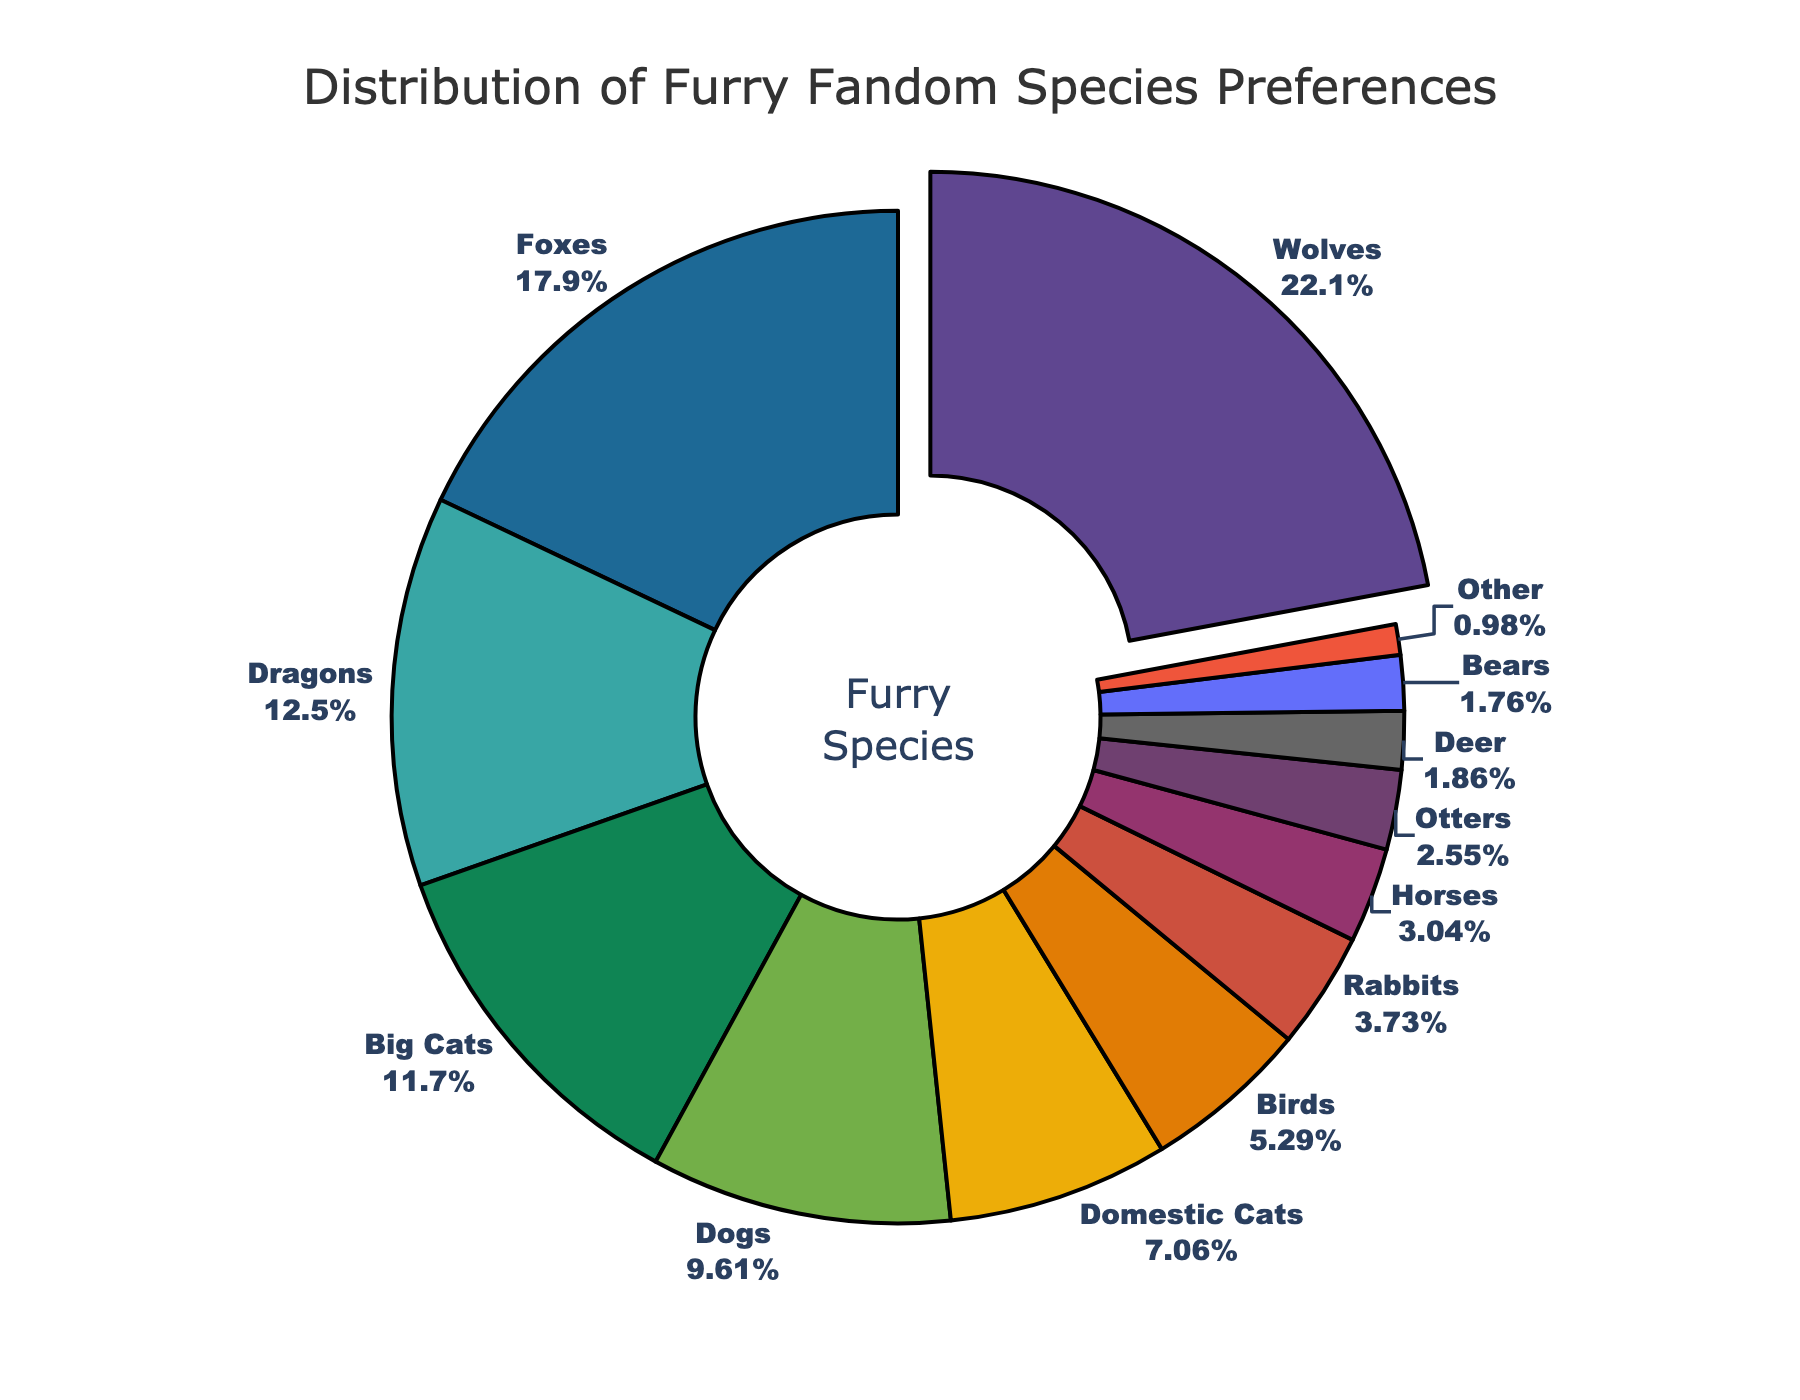1. Which species has the highest preference percentage? The figure shows that wolves have the highest percentage preference, highlighted prominently by being slightly pulled out from the rest of the pie chart.
Answer: Wolves 2. What is the combined preference percentage for Wolves and Foxes? To find this, sum the preference percentages of Wolves and Foxes: 22.5% + 18.3% = 40.8%.
Answer: 40.8% 3. How much higher is the preference for Wolves compared to Foxes? Subtract the percentage for Foxes from the percentage for Wolves: 22.5% - 18.3% = 4.2%.
Answer: 4.2% 4. Which species comes third in terms of preference percentage? The third-highest percentage in the pie chart is for Dragons, at 12.7%.
Answer: Dragons 5. Do Dogs or Domestic Cats have a higher preference percentage? By examining the pie chart, it shows that Dogs (9.8%) have a higher preference percentage than Domestic Cats (7.2%).
Answer: Dogs 6. What is the difference between the combined percentages of Big Cats and Dogs versus the combined percentages of Birds and Rabbits? Compute the combined percentages for Big Cats and Dogs: 11.9% + 9.8% = 21.7%. Then compute the combined percentages for Birds and Rabbits: 5.4% + 3.8% = 9.2%. Finally, subtract the latter from the former: 21.7% - 9.2% = 12.5%.
Answer: 12.5% 7. What percentage of the fandom prefers species other than the top three (Wolves, Foxes, Dragons)? Subtract the combined percentages of the top three species from 100%: 100% - (22.5% + 18.3% + 12.7%) = 100% - 53.5% = 46.5%.
Answer: 46.5% 8. Which species has the lowest preference percentage, and what is it? The pie chart shows that the 'Other' category has the lowest preference percentage at 1.0%.
Answer: Other, 1.0% 9. How many species have a preference percentage greater than 10%? By counting the sections of the pie chart, the species with a preference percentage greater than 10% are Wolves (22.5%), Foxes (18.3%), Dragons (12.7%), and Big Cats (11.9%), making a total of four species.
Answer: 4 10. By what percentage does the preference for Horses exceed the preference for Otters? Subtract the percentage for Otters from the percentage for Horses: 3.1% - 2.6% = 0.5%.
Answer: 0.5% 